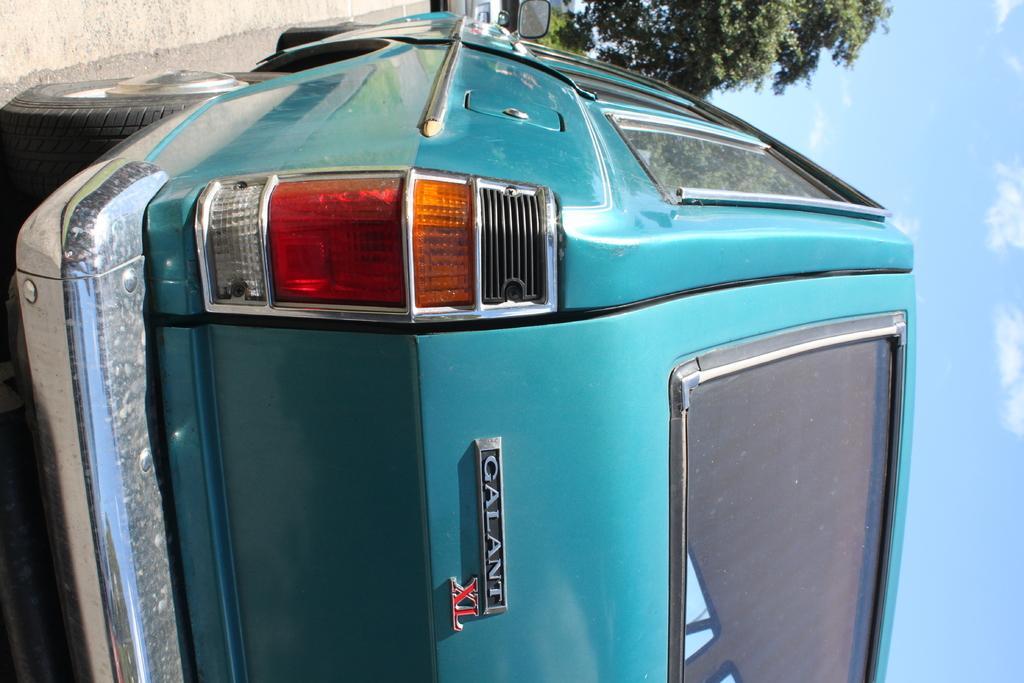In one or two sentences, can you explain what this image depicts? In this picture I can see some vehicles are on the road. 